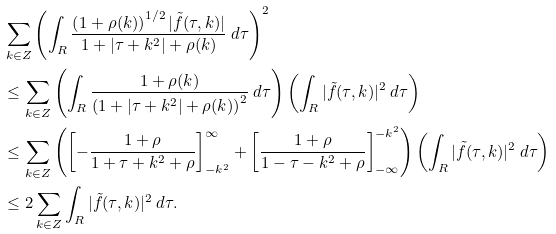Convert formula to latex. <formula><loc_0><loc_0><loc_500><loc_500>& \sum _ { k \in Z } \left ( \int _ { R } \frac { \left ( 1 + \rho ( k ) \right ) ^ { 1 / 2 } | \tilde { f } ( \tau , k ) | } { 1 + | \tau + k ^ { 2 } | + \rho ( k ) } \ d \tau \right ) ^ { 2 } \\ & \leq \sum _ { k \in Z } \left ( \int _ { R } \frac { 1 + \rho ( k ) } { \left ( 1 + | \tau + k ^ { 2 } | + \rho ( k ) \right ) ^ { 2 } } \ d \tau \right ) \left ( \int _ { R } | \tilde { f } ( \tau , k ) | ^ { 2 } \ d \tau \right ) \\ & \leq \sum _ { k \in Z } \left ( \left [ - \frac { 1 + \rho } { 1 + \tau + k ^ { 2 } + \rho } \right ] _ { - k ^ { 2 } } ^ { \infty } + \left [ \frac { 1 + \rho } { 1 - \tau - k ^ { 2 } + \rho } \right ] _ { - \infty } ^ { - k ^ { 2 } } \right ) \left ( \int _ { R } | \tilde { f } ( \tau , k ) | ^ { 2 } \ d \tau \right ) \\ & \leq 2 \sum _ { k \in Z } \int _ { R } | \tilde { f } ( \tau , k ) | ^ { 2 } \ d \tau .</formula> 